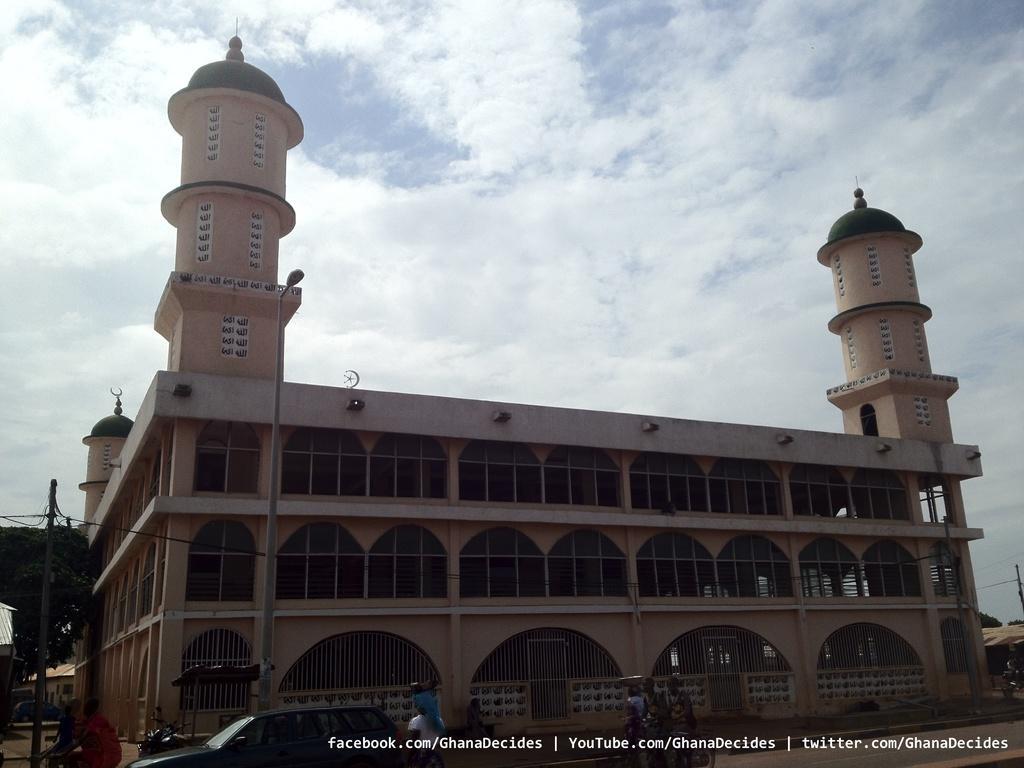Please provide a concise description of this image. In this image I can see a building which is cream in color. I can see few poles, few persons riding bicycles, a car, a motor bike and in the background I can see the sky and few trees. 